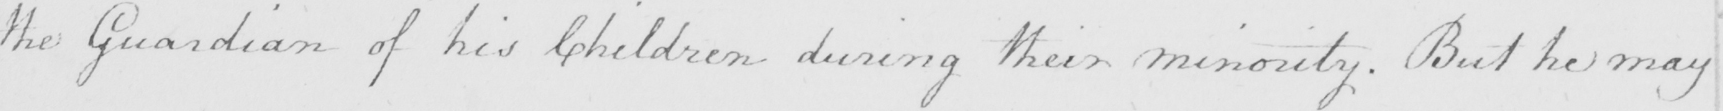Can you read and transcribe this handwriting? the Guardian of his Children during their minority . But he may 